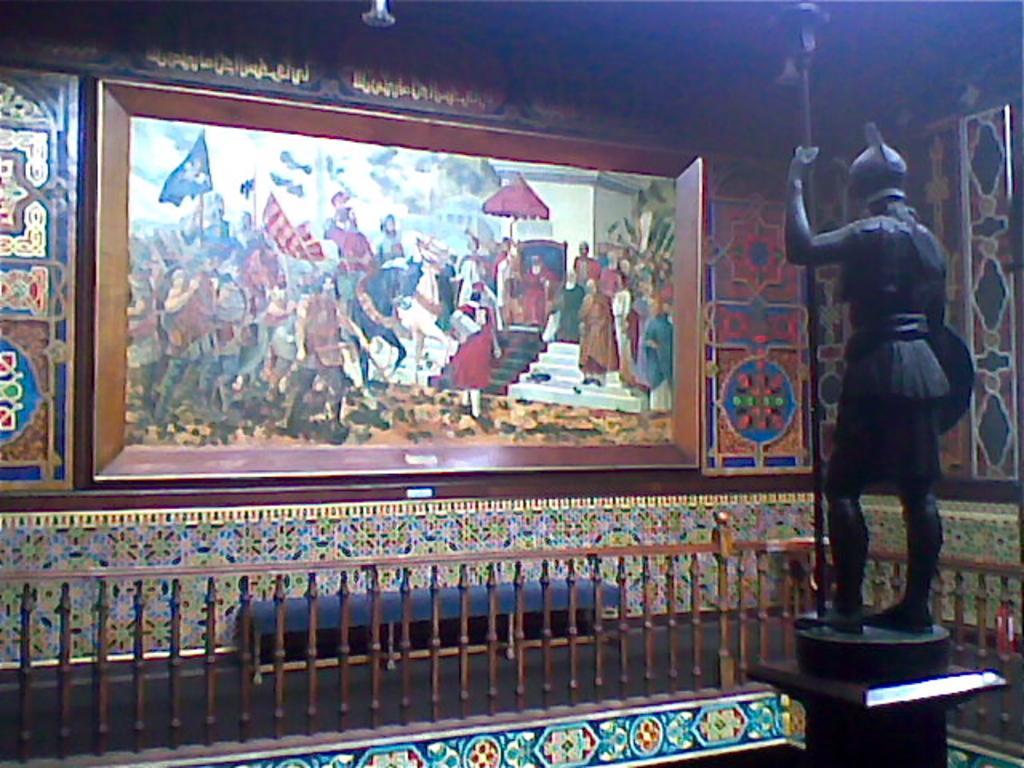Please provide a concise description of this image. In this image we can see a museum. There is a painting in the image. There is a sculpture in the image. There is a fencing in the image. 